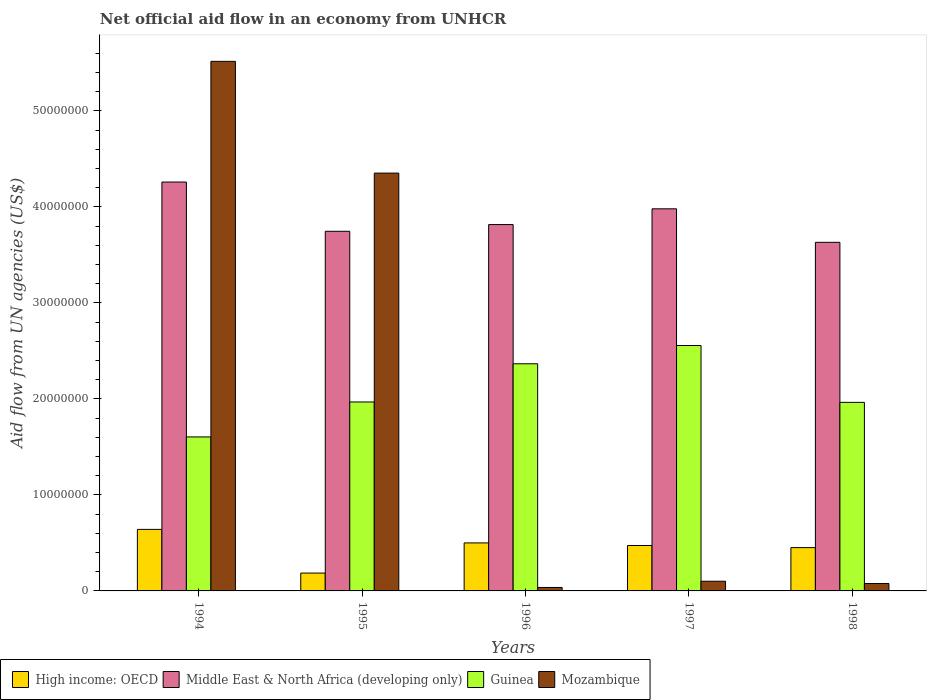How many different coloured bars are there?
Ensure brevity in your answer.  4. Are the number of bars per tick equal to the number of legend labels?
Your response must be concise. Yes. Are the number of bars on each tick of the X-axis equal?
Offer a very short reply. Yes. How many bars are there on the 3rd tick from the left?
Give a very brief answer. 4. In how many cases, is the number of bars for a given year not equal to the number of legend labels?
Keep it short and to the point. 0. What is the net official aid flow in High income: OECD in 1997?
Offer a very short reply. 4.73e+06. Across all years, what is the maximum net official aid flow in Mozambique?
Offer a terse response. 5.52e+07. In which year was the net official aid flow in Middle East & North Africa (developing only) minimum?
Provide a short and direct response. 1998. What is the total net official aid flow in Guinea in the graph?
Ensure brevity in your answer.  1.05e+08. What is the difference between the net official aid flow in High income: OECD in 1995 and that in 1998?
Offer a terse response. -2.65e+06. What is the difference between the net official aid flow in Mozambique in 1996 and the net official aid flow in Middle East & North Africa (developing only) in 1995?
Make the answer very short. -3.71e+07. What is the average net official aid flow in High income: OECD per year?
Your answer should be very brief. 4.50e+06. In the year 1996, what is the difference between the net official aid flow in Middle East & North Africa (developing only) and net official aid flow in High income: OECD?
Your answer should be very brief. 3.32e+07. What is the ratio of the net official aid flow in High income: OECD in 1995 to that in 1998?
Provide a succinct answer. 0.41. What is the difference between the highest and the second highest net official aid flow in Guinea?
Your answer should be very brief. 1.90e+06. What is the difference between the highest and the lowest net official aid flow in High income: OECD?
Offer a terse response. 4.55e+06. Is the sum of the net official aid flow in High income: OECD in 1995 and 1996 greater than the maximum net official aid flow in Guinea across all years?
Offer a very short reply. No. What does the 4th bar from the left in 1997 represents?
Your response must be concise. Mozambique. What does the 1st bar from the right in 1996 represents?
Give a very brief answer. Mozambique. What is the difference between two consecutive major ticks on the Y-axis?
Your answer should be compact. 1.00e+07. Are the values on the major ticks of Y-axis written in scientific E-notation?
Your answer should be compact. No. Does the graph contain any zero values?
Keep it short and to the point. No. Where does the legend appear in the graph?
Your answer should be compact. Bottom left. How many legend labels are there?
Offer a terse response. 4. What is the title of the graph?
Your response must be concise. Net official aid flow in an economy from UNHCR. Does "Niger" appear as one of the legend labels in the graph?
Ensure brevity in your answer.  No. What is the label or title of the Y-axis?
Provide a short and direct response. Aid flow from UN agencies (US$). What is the Aid flow from UN agencies (US$) in High income: OECD in 1994?
Your answer should be compact. 6.41e+06. What is the Aid flow from UN agencies (US$) of Middle East & North Africa (developing only) in 1994?
Make the answer very short. 4.26e+07. What is the Aid flow from UN agencies (US$) of Guinea in 1994?
Provide a short and direct response. 1.60e+07. What is the Aid flow from UN agencies (US$) in Mozambique in 1994?
Make the answer very short. 5.52e+07. What is the Aid flow from UN agencies (US$) in High income: OECD in 1995?
Provide a succinct answer. 1.86e+06. What is the Aid flow from UN agencies (US$) of Middle East & North Africa (developing only) in 1995?
Make the answer very short. 3.75e+07. What is the Aid flow from UN agencies (US$) of Guinea in 1995?
Provide a succinct answer. 1.97e+07. What is the Aid flow from UN agencies (US$) in Mozambique in 1995?
Your response must be concise. 4.35e+07. What is the Aid flow from UN agencies (US$) in High income: OECD in 1996?
Keep it short and to the point. 5.00e+06. What is the Aid flow from UN agencies (US$) of Middle East & North Africa (developing only) in 1996?
Ensure brevity in your answer.  3.82e+07. What is the Aid flow from UN agencies (US$) in Guinea in 1996?
Keep it short and to the point. 2.37e+07. What is the Aid flow from UN agencies (US$) of Mozambique in 1996?
Provide a short and direct response. 3.60e+05. What is the Aid flow from UN agencies (US$) of High income: OECD in 1997?
Your answer should be compact. 4.73e+06. What is the Aid flow from UN agencies (US$) in Middle East & North Africa (developing only) in 1997?
Your answer should be compact. 3.98e+07. What is the Aid flow from UN agencies (US$) in Guinea in 1997?
Provide a succinct answer. 2.56e+07. What is the Aid flow from UN agencies (US$) of Mozambique in 1997?
Ensure brevity in your answer.  1.01e+06. What is the Aid flow from UN agencies (US$) in High income: OECD in 1998?
Provide a short and direct response. 4.51e+06. What is the Aid flow from UN agencies (US$) of Middle East & North Africa (developing only) in 1998?
Provide a short and direct response. 3.63e+07. What is the Aid flow from UN agencies (US$) in Guinea in 1998?
Offer a terse response. 1.96e+07. What is the Aid flow from UN agencies (US$) of Mozambique in 1998?
Your response must be concise. 7.70e+05. Across all years, what is the maximum Aid flow from UN agencies (US$) in High income: OECD?
Offer a very short reply. 6.41e+06. Across all years, what is the maximum Aid flow from UN agencies (US$) of Middle East & North Africa (developing only)?
Provide a short and direct response. 4.26e+07. Across all years, what is the maximum Aid flow from UN agencies (US$) in Guinea?
Make the answer very short. 2.56e+07. Across all years, what is the maximum Aid flow from UN agencies (US$) of Mozambique?
Offer a terse response. 5.52e+07. Across all years, what is the minimum Aid flow from UN agencies (US$) in High income: OECD?
Keep it short and to the point. 1.86e+06. Across all years, what is the minimum Aid flow from UN agencies (US$) in Middle East & North Africa (developing only)?
Your answer should be compact. 3.63e+07. Across all years, what is the minimum Aid flow from UN agencies (US$) in Guinea?
Make the answer very short. 1.60e+07. What is the total Aid flow from UN agencies (US$) of High income: OECD in the graph?
Make the answer very short. 2.25e+07. What is the total Aid flow from UN agencies (US$) in Middle East & North Africa (developing only) in the graph?
Make the answer very short. 1.94e+08. What is the total Aid flow from UN agencies (US$) in Guinea in the graph?
Your answer should be compact. 1.05e+08. What is the total Aid flow from UN agencies (US$) in Mozambique in the graph?
Your answer should be very brief. 1.01e+08. What is the difference between the Aid flow from UN agencies (US$) of High income: OECD in 1994 and that in 1995?
Offer a terse response. 4.55e+06. What is the difference between the Aid flow from UN agencies (US$) of Middle East & North Africa (developing only) in 1994 and that in 1995?
Ensure brevity in your answer.  5.13e+06. What is the difference between the Aid flow from UN agencies (US$) in Guinea in 1994 and that in 1995?
Offer a terse response. -3.64e+06. What is the difference between the Aid flow from UN agencies (US$) in Mozambique in 1994 and that in 1995?
Offer a terse response. 1.16e+07. What is the difference between the Aid flow from UN agencies (US$) of High income: OECD in 1994 and that in 1996?
Offer a very short reply. 1.41e+06. What is the difference between the Aid flow from UN agencies (US$) in Middle East & North Africa (developing only) in 1994 and that in 1996?
Make the answer very short. 4.43e+06. What is the difference between the Aid flow from UN agencies (US$) in Guinea in 1994 and that in 1996?
Your answer should be very brief. -7.62e+06. What is the difference between the Aid flow from UN agencies (US$) in Mozambique in 1994 and that in 1996?
Ensure brevity in your answer.  5.48e+07. What is the difference between the Aid flow from UN agencies (US$) in High income: OECD in 1994 and that in 1997?
Offer a very short reply. 1.68e+06. What is the difference between the Aid flow from UN agencies (US$) of Middle East & North Africa (developing only) in 1994 and that in 1997?
Your response must be concise. 2.79e+06. What is the difference between the Aid flow from UN agencies (US$) in Guinea in 1994 and that in 1997?
Your answer should be very brief. -9.52e+06. What is the difference between the Aid flow from UN agencies (US$) in Mozambique in 1994 and that in 1997?
Ensure brevity in your answer.  5.42e+07. What is the difference between the Aid flow from UN agencies (US$) in High income: OECD in 1994 and that in 1998?
Keep it short and to the point. 1.90e+06. What is the difference between the Aid flow from UN agencies (US$) in Middle East & North Africa (developing only) in 1994 and that in 1998?
Your answer should be compact. 6.28e+06. What is the difference between the Aid flow from UN agencies (US$) in Guinea in 1994 and that in 1998?
Keep it short and to the point. -3.60e+06. What is the difference between the Aid flow from UN agencies (US$) in Mozambique in 1994 and that in 1998?
Your answer should be very brief. 5.44e+07. What is the difference between the Aid flow from UN agencies (US$) in High income: OECD in 1995 and that in 1996?
Ensure brevity in your answer.  -3.14e+06. What is the difference between the Aid flow from UN agencies (US$) of Middle East & North Africa (developing only) in 1995 and that in 1996?
Your response must be concise. -7.00e+05. What is the difference between the Aid flow from UN agencies (US$) in Guinea in 1995 and that in 1996?
Provide a short and direct response. -3.98e+06. What is the difference between the Aid flow from UN agencies (US$) of Mozambique in 1995 and that in 1996?
Your response must be concise. 4.32e+07. What is the difference between the Aid flow from UN agencies (US$) of High income: OECD in 1995 and that in 1997?
Ensure brevity in your answer.  -2.87e+06. What is the difference between the Aid flow from UN agencies (US$) of Middle East & North Africa (developing only) in 1995 and that in 1997?
Keep it short and to the point. -2.34e+06. What is the difference between the Aid flow from UN agencies (US$) in Guinea in 1995 and that in 1997?
Give a very brief answer. -5.88e+06. What is the difference between the Aid flow from UN agencies (US$) of Mozambique in 1995 and that in 1997?
Your answer should be very brief. 4.25e+07. What is the difference between the Aid flow from UN agencies (US$) of High income: OECD in 1995 and that in 1998?
Provide a succinct answer. -2.65e+06. What is the difference between the Aid flow from UN agencies (US$) of Middle East & North Africa (developing only) in 1995 and that in 1998?
Ensure brevity in your answer.  1.15e+06. What is the difference between the Aid flow from UN agencies (US$) in Guinea in 1995 and that in 1998?
Offer a very short reply. 4.00e+04. What is the difference between the Aid flow from UN agencies (US$) of Mozambique in 1995 and that in 1998?
Offer a very short reply. 4.28e+07. What is the difference between the Aid flow from UN agencies (US$) of Middle East & North Africa (developing only) in 1996 and that in 1997?
Offer a very short reply. -1.64e+06. What is the difference between the Aid flow from UN agencies (US$) of Guinea in 1996 and that in 1997?
Give a very brief answer. -1.90e+06. What is the difference between the Aid flow from UN agencies (US$) of Mozambique in 1996 and that in 1997?
Ensure brevity in your answer.  -6.50e+05. What is the difference between the Aid flow from UN agencies (US$) in High income: OECD in 1996 and that in 1998?
Provide a succinct answer. 4.90e+05. What is the difference between the Aid flow from UN agencies (US$) of Middle East & North Africa (developing only) in 1996 and that in 1998?
Offer a very short reply. 1.85e+06. What is the difference between the Aid flow from UN agencies (US$) in Guinea in 1996 and that in 1998?
Give a very brief answer. 4.02e+06. What is the difference between the Aid flow from UN agencies (US$) in Mozambique in 1996 and that in 1998?
Offer a terse response. -4.10e+05. What is the difference between the Aid flow from UN agencies (US$) in High income: OECD in 1997 and that in 1998?
Your answer should be compact. 2.20e+05. What is the difference between the Aid flow from UN agencies (US$) in Middle East & North Africa (developing only) in 1997 and that in 1998?
Offer a very short reply. 3.49e+06. What is the difference between the Aid flow from UN agencies (US$) of Guinea in 1997 and that in 1998?
Your answer should be very brief. 5.92e+06. What is the difference between the Aid flow from UN agencies (US$) in High income: OECD in 1994 and the Aid flow from UN agencies (US$) in Middle East & North Africa (developing only) in 1995?
Give a very brief answer. -3.10e+07. What is the difference between the Aid flow from UN agencies (US$) of High income: OECD in 1994 and the Aid flow from UN agencies (US$) of Guinea in 1995?
Provide a short and direct response. -1.33e+07. What is the difference between the Aid flow from UN agencies (US$) of High income: OECD in 1994 and the Aid flow from UN agencies (US$) of Mozambique in 1995?
Keep it short and to the point. -3.71e+07. What is the difference between the Aid flow from UN agencies (US$) in Middle East & North Africa (developing only) in 1994 and the Aid flow from UN agencies (US$) in Guinea in 1995?
Offer a very short reply. 2.29e+07. What is the difference between the Aid flow from UN agencies (US$) in Middle East & North Africa (developing only) in 1994 and the Aid flow from UN agencies (US$) in Mozambique in 1995?
Give a very brief answer. -9.30e+05. What is the difference between the Aid flow from UN agencies (US$) of Guinea in 1994 and the Aid flow from UN agencies (US$) of Mozambique in 1995?
Your answer should be compact. -2.75e+07. What is the difference between the Aid flow from UN agencies (US$) in High income: OECD in 1994 and the Aid flow from UN agencies (US$) in Middle East & North Africa (developing only) in 1996?
Provide a succinct answer. -3.18e+07. What is the difference between the Aid flow from UN agencies (US$) of High income: OECD in 1994 and the Aid flow from UN agencies (US$) of Guinea in 1996?
Give a very brief answer. -1.72e+07. What is the difference between the Aid flow from UN agencies (US$) in High income: OECD in 1994 and the Aid flow from UN agencies (US$) in Mozambique in 1996?
Provide a succinct answer. 6.05e+06. What is the difference between the Aid flow from UN agencies (US$) in Middle East & North Africa (developing only) in 1994 and the Aid flow from UN agencies (US$) in Guinea in 1996?
Provide a short and direct response. 1.89e+07. What is the difference between the Aid flow from UN agencies (US$) of Middle East & North Africa (developing only) in 1994 and the Aid flow from UN agencies (US$) of Mozambique in 1996?
Keep it short and to the point. 4.22e+07. What is the difference between the Aid flow from UN agencies (US$) of Guinea in 1994 and the Aid flow from UN agencies (US$) of Mozambique in 1996?
Your answer should be very brief. 1.57e+07. What is the difference between the Aid flow from UN agencies (US$) in High income: OECD in 1994 and the Aid flow from UN agencies (US$) in Middle East & North Africa (developing only) in 1997?
Keep it short and to the point. -3.34e+07. What is the difference between the Aid flow from UN agencies (US$) of High income: OECD in 1994 and the Aid flow from UN agencies (US$) of Guinea in 1997?
Your response must be concise. -1.92e+07. What is the difference between the Aid flow from UN agencies (US$) in High income: OECD in 1994 and the Aid flow from UN agencies (US$) in Mozambique in 1997?
Ensure brevity in your answer.  5.40e+06. What is the difference between the Aid flow from UN agencies (US$) of Middle East & North Africa (developing only) in 1994 and the Aid flow from UN agencies (US$) of Guinea in 1997?
Provide a succinct answer. 1.70e+07. What is the difference between the Aid flow from UN agencies (US$) in Middle East & North Africa (developing only) in 1994 and the Aid flow from UN agencies (US$) in Mozambique in 1997?
Offer a terse response. 4.16e+07. What is the difference between the Aid flow from UN agencies (US$) in Guinea in 1994 and the Aid flow from UN agencies (US$) in Mozambique in 1997?
Give a very brief answer. 1.50e+07. What is the difference between the Aid flow from UN agencies (US$) of High income: OECD in 1994 and the Aid flow from UN agencies (US$) of Middle East & North Africa (developing only) in 1998?
Provide a succinct answer. -2.99e+07. What is the difference between the Aid flow from UN agencies (US$) of High income: OECD in 1994 and the Aid flow from UN agencies (US$) of Guinea in 1998?
Your answer should be compact. -1.32e+07. What is the difference between the Aid flow from UN agencies (US$) of High income: OECD in 1994 and the Aid flow from UN agencies (US$) of Mozambique in 1998?
Your answer should be compact. 5.64e+06. What is the difference between the Aid flow from UN agencies (US$) of Middle East & North Africa (developing only) in 1994 and the Aid flow from UN agencies (US$) of Guinea in 1998?
Your answer should be compact. 2.30e+07. What is the difference between the Aid flow from UN agencies (US$) in Middle East & North Africa (developing only) in 1994 and the Aid flow from UN agencies (US$) in Mozambique in 1998?
Make the answer very short. 4.18e+07. What is the difference between the Aid flow from UN agencies (US$) in Guinea in 1994 and the Aid flow from UN agencies (US$) in Mozambique in 1998?
Offer a very short reply. 1.53e+07. What is the difference between the Aid flow from UN agencies (US$) in High income: OECD in 1995 and the Aid flow from UN agencies (US$) in Middle East & North Africa (developing only) in 1996?
Offer a terse response. -3.63e+07. What is the difference between the Aid flow from UN agencies (US$) of High income: OECD in 1995 and the Aid flow from UN agencies (US$) of Guinea in 1996?
Give a very brief answer. -2.18e+07. What is the difference between the Aid flow from UN agencies (US$) in High income: OECD in 1995 and the Aid flow from UN agencies (US$) in Mozambique in 1996?
Ensure brevity in your answer.  1.50e+06. What is the difference between the Aid flow from UN agencies (US$) of Middle East & North Africa (developing only) in 1995 and the Aid flow from UN agencies (US$) of Guinea in 1996?
Give a very brief answer. 1.38e+07. What is the difference between the Aid flow from UN agencies (US$) in Middle East & North Africa (developing only) in 1995 and the Aid flow from UN agencies (US$) in Mozambique in 1996?
Your answer should be compact. 3.71e+07. What is the difference between the Aid flow from UN agencies (US$) of Guinea in 1995 and the Aid flow from UN agencies (US$) of Mozambique in 1996?
Give a very brief answer. 1.93e+07. What is the difference between the Aid flow from UN agencies (US$) of High income: OECD in 1995 and the Aid flow from UN agencies (US$) of Middle East & North Africa (developing only) in 1997?
Provide a short and direct response. -3.79e+07. What is the difference between the Aid flow from UN agencies (US$) of High income: OECD in 1995 and the Aid flow from UN agencies (US$) of Guinea in 1997?
Ensure brevity in your answer.  -2.37e+07. What is the difference between the Aid flow from UN agencies (US$) of High income: OECD in 1995 and the Aid flow from UN agencies (US$) of Mozambique in 1997?
Ensure brevity in your answer.  8.50e+05. What is the difference between the Aid flow from UN agencies (US$) in Middle East & North Africa (developing only) in 1995 and the Aid flow from UN agencies (US$) in Guinea in 1997?
Give a very brief answer. 1.19e+07. What is the difference between the Aid flow from UN agencies (US$) in Middle East & North Africa (developing only) in 1995 and the Aid flow from UN agencies (US$) in Mozambique in 1997?
Provide a short and direct response. 3.64e+07. What is the difference between the Aid flow from UN agencies (US$) of Guinea in 1995 and the Aid flow from UN agencies (US$) of Mozambique in 1997?
Your answer should be very brief. 1.87e+07. What is the difference between the Aid flow from UN agencies (US$) in High income: OECD in 1995 and the Aid flow from UN agencies (US$) in Middle East & North Africa (developing only) in 1998?
Provide a short and direct response. -3.44e+07. What is the difference between the Aid flow from UN agencies (US$) in High income: OECD in 1995 and the Aid flow from UN agencies (US$) in Guinea in 1998?
Your answer should be very brief. -1.78e+07. What is the difference between the Aid flow from UN agencies (US$) in High income: OECD in 1995 and the Aid flow from UN agencies (US$) in Mozambique in 1998?
Keep it short and to the point. 1.09e+06. What is the difference between the Aid flow from UN agencies (US$) in Middle East & North Africa (developing only) in 1995 and the Aid flow from UN agencies (US$) in Guinea in 1998?
Offer a terse response. 1.78e+07. What is the difference between the Aid flow from UN agencies (US$) of Middle East & North Africa (developing only) in 1995 and the Aid flow from UN agencies (US$) of Mozambique in 1998?
Make the answer very short. 3.67e+07. What is the difference between the Aid flow from UN agencies (US$) of Guinea in 1995 and the Aid flow from UN agencies (US$) of Mozambique in 1998?
Provide a short and direct response. 1.89e+07. What is the difference between the Aid flow from UN agencies (US$) in High income: OECD in 1996 and the Aid flow from UN agencies (US$) in Middle East & North Africa (developing only) in 1997?
Ensure brevity in your answer.  -3.48e+07. What is the difference between the Aid flow from UN agencies (US$) in High income: OECD in 1996 and the Aid flow from UN agencies (US$) in Guinea in 1997?
Give a very brief answer. -2.06e+07. What is the difference between the Aid flow from UN agencies (US$) of High income: OECD in 1996 and the Aid flow from UN agencies (US$) of Mozambique in 1997?
Offer a very short reply. 3.99e+06. What is the difference between the Aid flow from UN agencies (US$) in Middle East & North Africa (developing only) in 1996 and the Aid flow from UN agencies (US$) in Guinea in 1997?
Ensure brevity in your answer.  1.26e+07. What is the difference between the Aid flow from UN agencies (US$) of Middle East & North Africa (developing only) in 1996 and the Aid flow from UN agencies (US$) of Mozambique in 1997?
Provide a succinct answer. 3.72e+07. What is the difference between the Aid flow from UN agencies (US$) in Guinea in 1996 and the Aid flow from UN agencies (US$) in Mozambique in 1997?
Make the answer very short. 2.26e+07. What is the difference between the Aid flow from UN agencies (US$) of High income: OECD in 1996 and the Aid flow from UN agencies (US$) of Middle East & North Africa (developing only) in 1998?
Your answer should be compact. -3.13e+07. What is the difference between the Aid flow from UN agencies (US$) of High income: OECD in 1996 and the Aid flow from UN agencies (US$) of Guinea in 1998?
Give a very brief answer. -1.46e+07. What is the difference between the Aid flow from UN agencies (US$) of High income: OECD in 1996 and the Aid flow from UN agencies (US$) of Mozambique in 1998?
Provide a short and direct response. 4.23e+06. What is the difference between the Aid flow from UN agencies (US$) of Middle East & North Africa (developing only) in 1996 and the Aid flow from UN agencies (US$) of Guinea in 1998?
Provide a succinct answer. 1.85e+07. What is the difference between the Aid flow from UN agencies (US$) of Middle East & North Africa (developing only) in 1996 and the Aid flow from UN agencies (US$) of Mozambique in 1998?
Your answer should be very brief. 3.74e+07. What is the difference between the Aid flow from UN agencies (US$) of Guinea in 1996 and the Aid flow from UN agencies (US$) of Mozambique in 1998?
Provide a short and direct response. 2.29e+07. What is the difference between the Aid flow from UN agencies (US$) in High income: OECD in 1997 and the Aid flow from UN agencies (US$) in Middle East & North Africa (developing only) in 1998?
Your answer should be very brief. -3.16e+07. What is the difference between the Aid flow from UN agencies (US$) of High income: OECD in 1997 and the Aid flow from UN agencies (US$) of Guinea in 1998?
Your answer should be compact. -1.49e+07. What is the difference between the Aid flow from UN agencies (US$) in High income: OECD in 1997 and the Aid flow from UN agencies (US$) in Mozambique in 1998?
Offer a terse response. 3.96e+06. What is the difference between the Aid flow from UN agencies (US$) in Middle East & North Africa (developing only) in 1997 and the Aid flow from UN agencies (US$) in Guinea in 1998?
Provide a succinct answer. 2.02e+07. What is the difference between the Aid flow from UN agencies (US$) in Middle East & North Africa (developing only) in 1997 and the Aid flow from UN agencies (US$) in Mozambique in 1998?
Offer a very short reply. 3.90e+07. What is the difference between the Aid flow from UN agencies (US$) in Guinea in 1997 and the Aid flow from UN agencies (US$) in Mozambique in 1998?
Give a very brief answer. 2.48e+07. What is the average Aid flow from UN agencies (US$) in High income: OECD per year?
Keep it short and to the point. 4.50e+06. What is the average Aid flow from UN agencies (US$) of Middle East & North Africa (developing only) per year?
Provide a short and direct response. 3.89e+07. What is the average Aid flow from UN agencies (US$) of Guinea per year?
Provide a succinct answer. 2.09e+07. What is the average Aid flow from UN agencies (US$) in Mozambique per year?
Provide a succinct answer. 2.02e+07. In the year 1994, what is the difference between the Aid flow from UN agencies (US$) in High income: OECD and Aid flow from UN agencies (US$) in Middle East & North Africa (developing only)?
Make the answer very short. -3.62e+07. In the year 1994, what is the difference between the Aid flow from UN agencies (US$) in High income: OECD and Aid flow from UN agencies (US$) in Guinea?
Offer a very short reply. -9.63e+06. In the year 1994, what is the difference between the Aid flow from UN agencies (US$) in High income: OECD and Aid flow from UN agencies (US$) in Mozambique?
Your response must be concise. -4.88e+07. In the year 1994, what is the difference between the Aid flow from UN agencies (US$) in Middle East & North Africa (developing only) and Aid flow from UN agencies (US$) in Guinea?
Keep it short and to the point. 2.66e+07. In the year 1994, what is the difference between the Aid flow from UN agencies (US$) in Middle East & North Africa (developing only) and Aid flow from UN agencies (US$) in Mozambique?
Your response must be concise. -1.26e+07. In the year 1994, what is the difference between the Aid flow from UN agencies (US$) in Guinea and Aid flow from UN agencies (US$) in Mozambique?
Your response must be concise. -3.91e+07. In the year 1995, what is the difference between the Aid flow from UN agencies (US$) in High income: OECD and Aid flow from UN agencies (US$) in Middle East & North Africa (developing only)?
Your answer should be compact. -3.56e+07. In the year 1995, what is the difference between the Aid flow from UN agencies (US$) of High income: OECD and Aid flow from UN agencies (US$) of Guinea?
Offer a terse response. -1.78e+07. In the year 1995, what is the difference between the Aid flow from UN agencies (US$) in High income: OECD and Aid flow from UN agencies (US$) in Mozambique?
Your response must be concise. -4.17e+07. In the year 1995, what is the difference between the Aid flow from UN agencies (US$) in Middle East & North Africa (developing only) and Aid flow from UN agencies (US$) in Guinea?
Provide a succinct answer. 1.78e+07. In the year 1995, what is the difference between the Aid flow from UN agencies (US$) in Middle East & North Africa (developing only) and Aid flow from UN agencies (US$) in Mozambique?
Provide a succinct answer. -6.06e+06. In the year 1995, what is the difference between the Aid flow from UN agencies (US$) in Guinea and Aid flow from UN agencies (US$) in Mozambique?
Offer a very short reply. -2.38e+07. In the year 1996, what is the difference between the Aid flow from UN agencies (US$) in High income: OECD and Aid flow from UN agencies (US$) in Middle East & North Africa (developing only)?
Your response must be concise. -3.32e+07. In the year 1996, what is the difference between the Aid flow from UN agencies (US$) of High income: OECD and Aid flow from UN agencies (US$) of Guinea?
Your answer should be compact. -1.87e+07. In the year 1996, what is the difference between the Aid flow from UN agencies (US$) in High income: OECD and Aid flow from UN agencies (US$) in Mozambique?
Offer a very short reply. 4.64e+06. In the year 1996, what is the difference between the Aid flow from UN agencies (US$) in Middle East & North Africa (developing only) and Aid flow from UN agencies (US$) in Guinea?
Make the answer very short. 1.45e+07. In the year 1996, what is the difference between the Aid flow from UN agencies (US$) in Middle East & North Africa (developing only) and Aid flow from UN agencies (US$) in Mozambique?
Provide a short and direct response. 3.78e+07. In the year 1996, what is the difference between the Aid flow from UN agencies (US$) of Guinea and Aid flow from UN agencies (US$) of Mozambique?
Your answer should be compact. 2.33e+07. In the year 1997, what is the difference between the Aid flow from UN agencies (US$) in High income: OECD and Aid flow from UN agencies (US$) in Middle East & North Africa (developing only)?
Offer a very short reply. -3.51e+07. In the year 1997, what is the difference between the Aid flow from UN agencies (US$) in High income: OECD and Aid flow from UN agencies (US$) in Guinea?
Your answer should be compact. -2.08e+07. In the year 1997, what is the difference between the Aid flow from UN agencies (US$) in High income: OECD and Aid flow from UN agencies (US$) in Mozambique?
Offer a terse response. 3.72e+06. In the year 1997, what is the difference between the Aid flow from UN agencies (US$) in Middle East & North Africa (developing only) and Aid flow from UN agencies (US$) in Guinea?
Offer a terse response. 1.42e+07. In the year 1997, what is the difference between the Aid flow from UN agencies (US$) of Middle East & North Africa (developing only) and Aid flow from UN agencies (US$) of Mozambique?
Provide a short and direct response. 3.88e+07. In the year 1997, what is the difference between the Aid flow from UN agencies (US$) of Guinea and Aid flow from UN agencies (US$) of Mozambique?
Ensure brevity in your answer.  2.46e+07. In the year 1998, what is the difference between the Aid flow from UN agencies (US$) in High income: OECD and Aid flow from UN agencies (US$) in Middle East & North Africa (developing only)?
Make the answer very short. -3.18e+07. In the year 1998, what is the difference between the Aid flow from UN agencies (US$) in High income: OECD and Aid flow from UN agencies (US$) in Guinea?
Offer a terse response. -1.51e+07. In the year 1998, what is the difference between the Aid flow from UN agencies (US$) in High income: OECD and Aid flow from UN agencies (US$) in Mozambique?
Ensure brevity in your answer.  3.74e+06. In the year 1998, what is the difference between the Aid flow from UN agencies (US$) in Middle East & North Africa (developing only) and Aid flow from UN agencies (US$) in Guinea?
Your response must be concise. 1.67e+07. In the year 1998, what is the difference between the Aid flow from UN agencies (US$) of Middle East & North Africa (developing only) and Aid flow from UN agencies (US$) of Mozambique?
Your answer should be compact. 3.55e+07. In the year 1998, what is the difference between the Aid flow from UN agencies (US$) in Guinea and Aid flow from UN agencies (US$) in Mozambique?
Make the answer very short. 1.89e+07. What is the ratio of the Aid flow from UN agencies (US$) in High income: OECD in 1994 to that in 1995?
Give a very brief answer. 3.45. What is the ratio of the Aid flow from UN agencies (US$) in Middle East & North Africa (developing only) in 1994 to that in 1995?
Provide a succinct answer. 1.14. What is the ratio of the Aid flow from UN agencies (US$) in Guinea in 1994 to that in 1995?
Your answer should be compact. 0.81. What is the ratio of the Aid flow from UN agencies (US$) of Mozambique in 1994 to that in 1995?
Your answer should be very brief. 1.27. What is the ratio of the Aid flow from UN agencies (US$) of High income: OECD in 1994 to that in 1996?
Offer a very short reply. 1.28. What is the ratio of the Aid flow from UN agencies (US$) in Middle East & North Africa (developing only) in 1994 to that in 1996?
Provide a short and direct response. 1.12. What is the ratio of the Aid flow from UN agencies (US$) in Guinea in 1994 to that in 1996?
Provide a succinct answer. 0.68. What is the ratio of the Aid flow from UN agencies (US$) of Mozambique in 1994 to that in 1996?
Offer a terse response. 153.22. What is the ratio of the Aid flow from UN agencies (US$) of High income: OECD in 1994 to that in 1997?
Your response must be concise. 1.36. What is the ratio of the Aid flow from UN agencies (US$) of Middle East & North Africa (developing only) in 1994 to that in 1997?
Make the answer very short. 1.07. What is the ratio of the Aid flow from UN agencies (US$) of Guinea in 1994 to that in 1997?
Ensure brevity in your answer.  0.63. What is the ratio of the Aid flow from UN agencies (US$) in Mozambique in 1994 to that in 1997?
Your response must be concise. 54.61. What is the ratio of the Aid flow from UN agencies (US$) in High income: OECD in 1994 to that in 1998?
Provide a succinct answer. 1.42. What is the ratio of the Aid flow from UN agencies (US$) in Middle East & North Africa (developing only) in 1994 to that in 1998?
Your answer should be compact. 1.17. What is the ratio of the Aid flow from UN agencies (US$) in Guinea in 1994 to that in 1998?
Your answer should be compact. 0.82. What is the ratio of the Aid flow from UN agencies (US$) of Mozambique in 1994 to that in 1998?
Offer a very short reply. 71.64. What is the ratio of the Aid flow from UN agencies (US$) in High income: OECD in 1995 to that in 1996?
Offer a very short reply. 0.37. What is the ratio of the Aid flow from UN agencies (US$) in Middle East & North Africa (developing only) in 1995 to that in 1996?
Provide a short and direct response. 0.98. What is the ratio of the Aid flow from UN agencies (US$) of Guinea in 1995 to that in 1996?
Ensure brevity in your answer.  0.83. What is the ratio of the Aid flow from UN agencies (US$) in Mozambique in 1995 to that in 1996?
Keep it short and to the point. 120.89. What is the ratio of the Aid flow from UN agencies (US$) in High income: OECD in 1995 to that in 1997?
Keep it short and to the point. 0.39. What is the ratio of the Aid flow from UN agencies (US$) of Middle East & North Africa (developing only) in 1995 to that in 1997?
Your answer should be compact. 0.94. What is the ratio of the Aid flow from UN agencies (US$) in Guinea in 1995 to that in 1997?
Provide a succinct answer. 0.77. What is the ratio of the Aid flow from UN agencies (US$) in Mozambique in 1995 to that in 1997?
Your answer should be very brief. 43.09. What is the ratio of the Aid flow from UN agencies (US$) in High income: OECD in 1995 to that in 1998?
Give a very brief answer. 0.41. What is the ratio of the Aid flow from UN agencies (US$) of Middle East & North Africa (developing only) in 1995 to that in 1998?
Make the answer very short. 1.03. What is the ratio of the Aid flow from UN agencies (US$) of Guinea in 1995 to that in 1998?
Your answer should be compact. 1. What is the ratio of the Aid flow from UN agencies (US$) of Mozambique in 1995 to that in 1998?
Provide a succinct answer. 56.52. What is the ratio of the Aid flow from UN agencies (US$) in High income: OECD in 1996 to that in 1997?
Give a very brief answer. 1.06. What is the ratio of the Aid flow from UN agencies (US$) in Middle East & North Africa (developing only) in 1996 to that in 1997?
Give a very brief answer. 0.96. What is the ratio of the Aid flow from UN agencies (US$) in Guinea in 1996 to that in 1997?
Provide a succinct answer. 0.93. What is the ratio of the Aid flow from UN agencies (US$) in Mozambique in 1996 to that in 1997?
Offer a terse response. 0.36. What is the ratio of the Aid flow from UN agencies (US$) of High income: OECD in 1996 to that in 1998?
Your answer should be very brief. 1.11. What is the ratio of the Aid flow from UN agencies (US$) in Middle East & North Africa (developing only) in 1996 to that in 1998?
Make the answer very short. 1.05. What is the ratio of the Aid flow from UN agencies (US$) of Guinea in 1996 to that in 1998?
Your answer should be compact. 1.2. What is the ratio of the Aid flow from UN agencies (US$) of Mozambique in 1996 to that in 1998?
Your answer should be compact. 0.47. What is the ratio of the Aid flow from UN agencies (US$) in High income: OECD in 1997 to that in 1998?
Make the answer very short. 1.05. What is the ratio of the Aid flow from UN agencies (US$) of Middle East & North Africa (developing only) in 1997 to that in 1998?
Your response must be concise. 1.1. What is the ratio of the Aid flow from UN agencies (US$) of Guinea in 1997 to that in 1998?
Offer a very short reply. 1.3. What is the ratio of the Aid flow from UN agencies (US$) of Mozambique in 1997 to that in 1998?
Your answer should be very brief. 1.31. What is the difference between the highest and the second highest Aid flow from UN agencies (US$) of High income: OECD?
Offer a very short reply. 1.41e+06. What is the difference between the highest and the second highest Aid flow from UN agencies (US$) of Middle East & North Africa (developing only)?
Your response must be concise. 2.79e+06. What is the difference between the highest and the second highest Aid flow from UN agencies (US$) of Guinea?
Provide a succinct answer. 1.90e+06. What is the difference between the highest and the second highest Aid flow from UN agencies (US$) in Mozambique?
Provide a succinct answer. 1.16e+07. What is the difference between the highest and the lowest Aid flow from UN agencies (US$) in High income: OECD?
Keep it short and to the point. 4.55e+06. What is the difference between the highest and the lowest Aid flow from UN agencies (US$) of Middle East & North Africa (developing only)?
Make the answer very short. 6.28e+06. What is the difference between the highest and the lowest Aid flow from UN agencies (US$) in Guinea?
Provide a short and direct response. 9.52e+06. What is the difference between the highest and the lowest Aid flow from UN agencies (US$) of Mozambique?
Offer a terse response. 5.48e+07. 